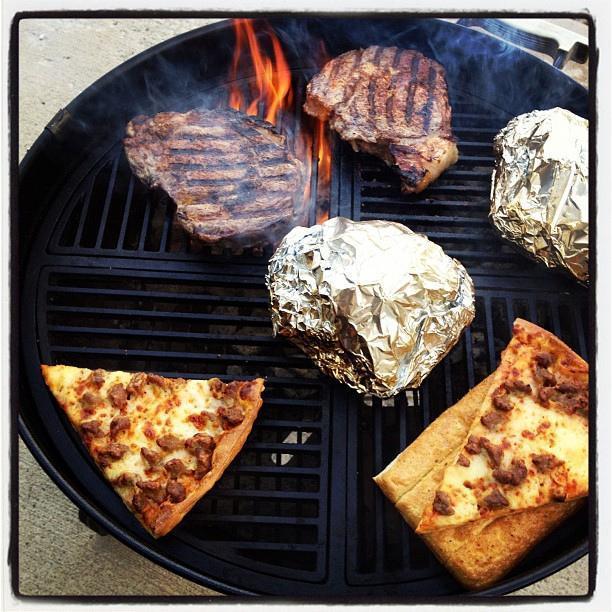How many pizzas are there?
Give a very brief answer. 1. 